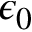<formula> <loc_0><loc_0><loc_500><loc_500>\epsilon _ { 0 }</formula> 